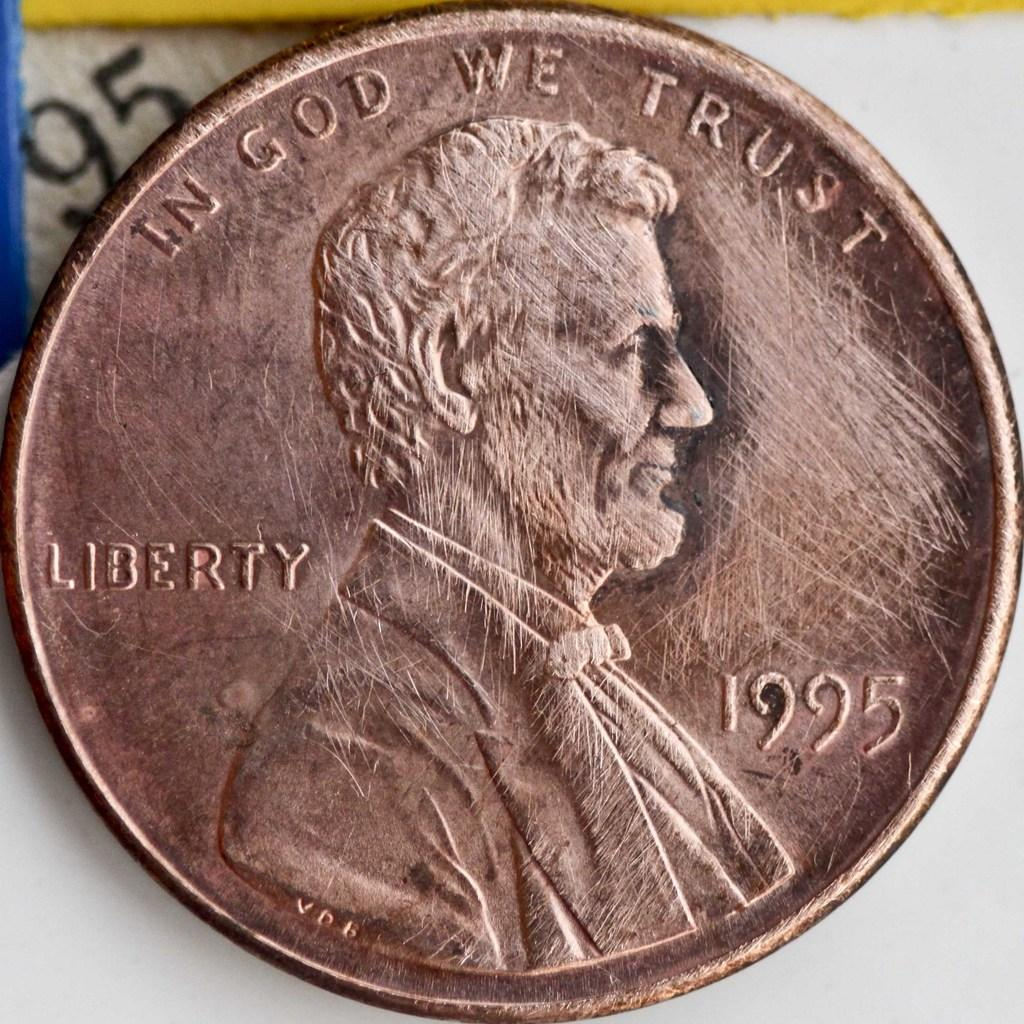<image>
Provide a brief description of the given image. In God we trust written on a brown penny 